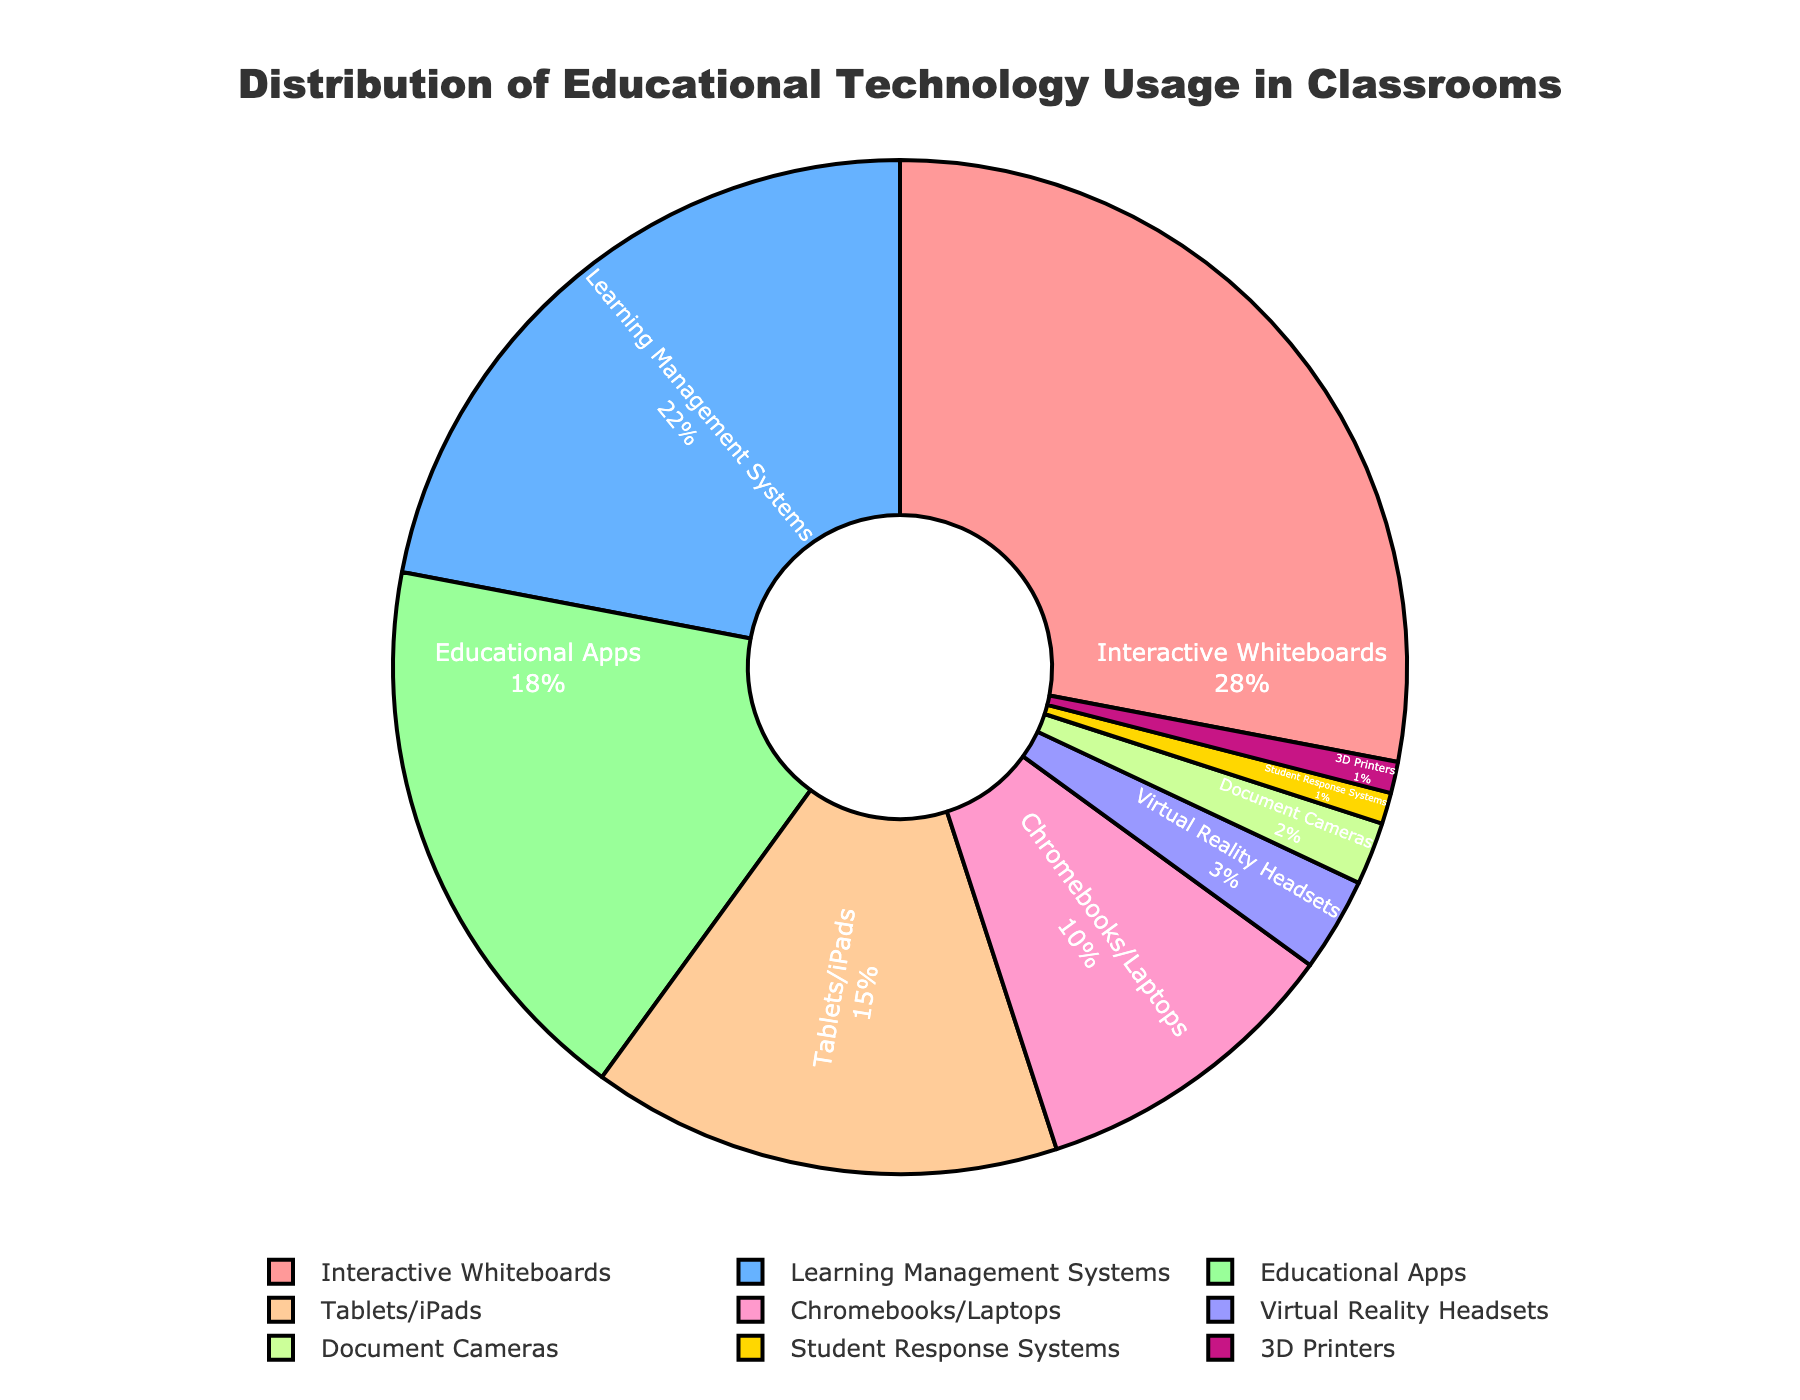What percentage of technology usage do Interactive Whiteboards and Learning Management Systems together account for? To find the combined percentage of Interactive Whiteboards and Learning Management Systems, add their individual percentages: 28% (Interactive Whiteboards) + 22% (Learning Management Systems) = 50%.
Answer: 50% Which technology type has the smallest usage percentage? By examining the chart, the smallest percentage is shared by 3D Printers and Student Response Systems, both at 1%.
Answer: 3D Printers and Student Response Systems Is the usage percentage of Educational Apps greater than that of Tablets/iPads? If yes, by how much? Educational Apps have a usage percentage of 18%, while Tablets/iPads have 15%. Subtract the two percentages: 18% - 15% = 3%.
Answer: Yes, by 3% How much more is the combined usage of Chromebooks/Laptops and Document Cameras compared to Virtual Reality Headsets? Calculate the combined usage of Chromebooks/Laptops and Document Cameras: 10% (Chromebooks/Laptops) + 2% (Document Cameras) = 12%, then subtract the 3% usage of Virtual Reality Headsets from this value: 12% - 3% = 9%.
Answer: 9% Which technology type is represented by the yellow segment in the pie chart? The color yellow represents Document Cameras in the pie chart.
Answer: Document Cameras 